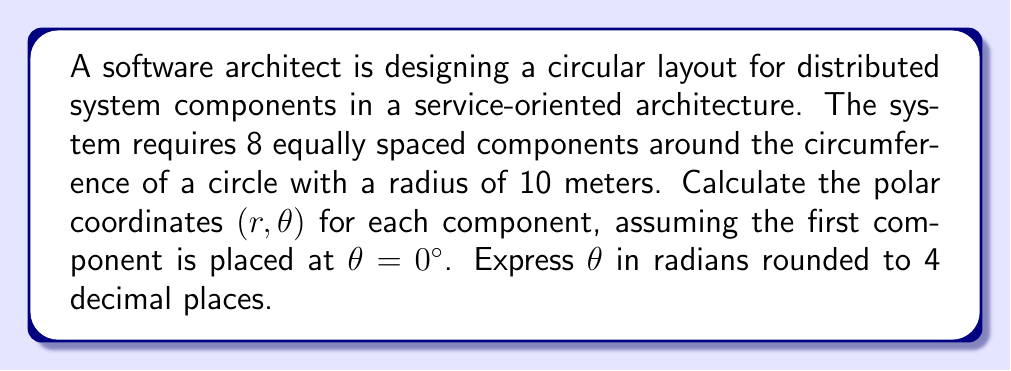Teach me how to tackle this problem. To solve this problem, we need to follow these steps:

1. Determine the angle between each component:
   The total angle of a circle is $2\pi$ radians or $360°$. With 8 components, the angle between each component is:
   $$\Delta \theta = \frac{2\pi}{8} = \frac{\pi}{4} \approx 0.7854 \text{ radians}$$

2. Calculate the polar coordinates for each component:
   - The radius $r$ is constant for all components: 10 meters
   - The angle $\theta$ for each component is a multiple of $\Delta \theta$

   Component 1: $(10, 0)$
   Component 2: $(10, \frac{\pi}{4})$
   Component 3: $(10, \frac{\pi}{2})$
   Component 4: $(10, \frac{3\pi}{4})$
   Component 5: $(10, \pi)$
   Component 6: $(10, \frac{5\pi}{4})$
   Component 7: $(10, \frac{3\pi}{2})$
   Component 8: $(10, \frac{7\pi}{4})$

3. Round $\theta$ to 4 decimal places:

[asy]
import geometry;

size(200);
draw(circle((0,0),10));
for(int i=0; i<8; ++i) {
  dot(10*dir(i*45°));
  label("C"+(string)(i+1), 11*dir(i*45°), dir(i*45°));
}
draw(Arc((0,0),10,0,45));
label("$\frac{\pi}{4}$", 5*dir(22.5°), E);
[/asy]
Answer: The polar coordinates $(r, \theta)$ for the 8 components are:

1. $(10, 0)$
2. $(10, 0.7854)$
3. $(10, 1.5708)$
4. $(10, 2.3562)$
5. $(10, 3.1416)$
6. $(10, 3.9270)$
7. $(10, 4.7124)$
8. $(10, 5.4978)$

Where $r$ is in meters and $\theta$ is in radians, rounded to 4 decimal places. 